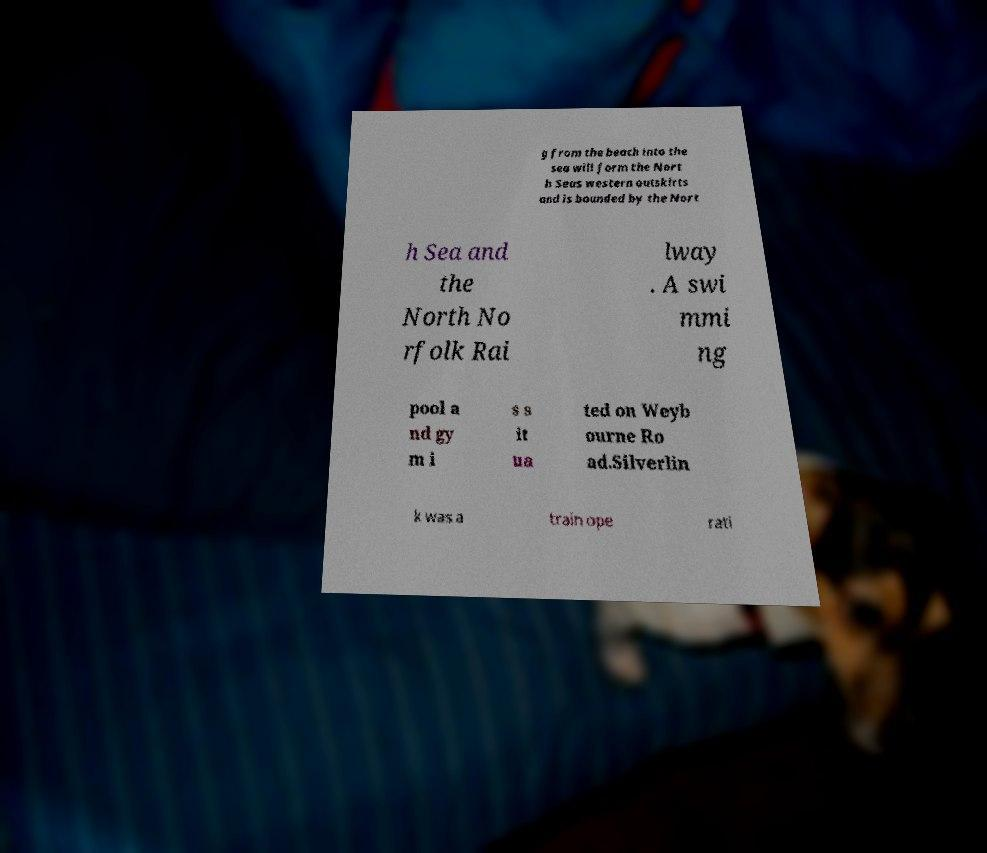What messages or text are displayed in this image? I need them in a readable, typed format. g from the beach into the sea will form the Nort h Seas western outskirts and is bounded by the Nort h Sea and the North No rfolk Rai lway . A swi mmi ng pool a nd gy m i s s it ua ted on Weyb ourne Ro ad.Silverlin k was a train ope rati 